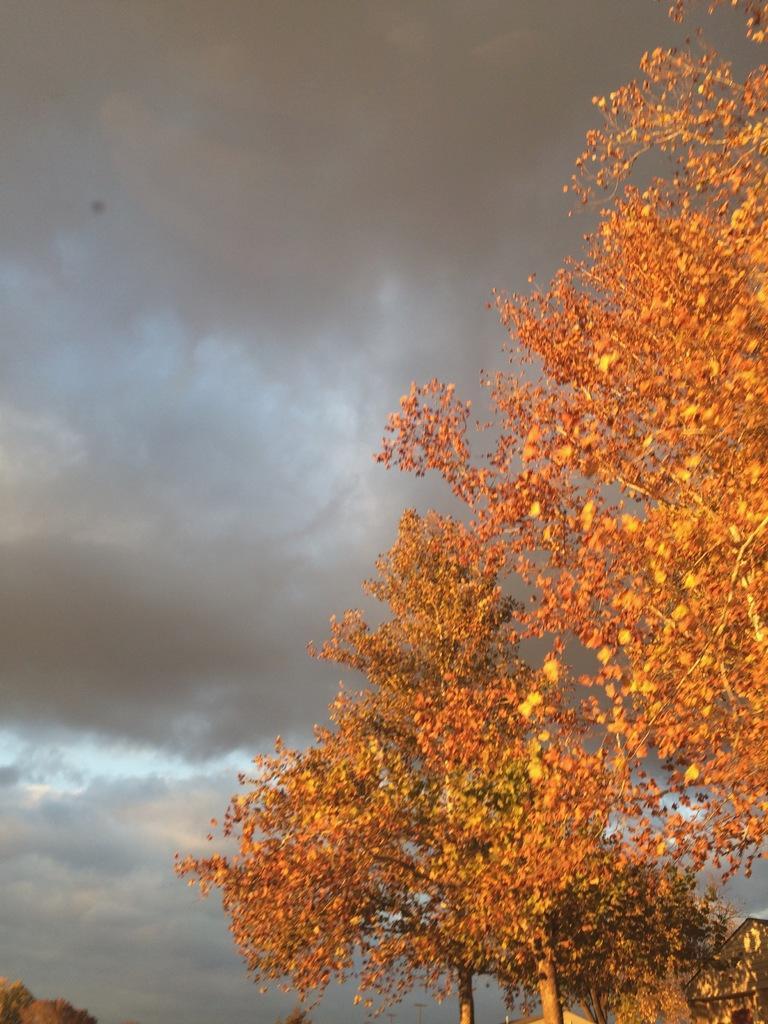How would you summarize this image in a sentence or two? There are trees and the leaves are orange in color and the sky is cloudy. 